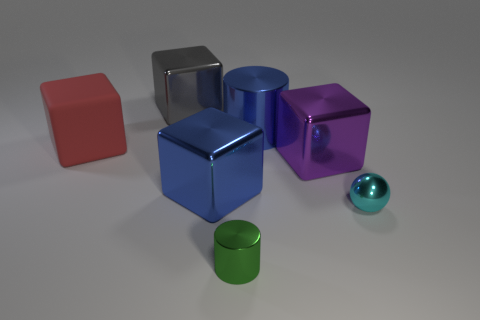Is there any other thing that has the same material as the red object?
Provide a short and direct response. No. What number of big gray things are on the right side of the blue shiny thing behind the big thing that is to the left of the gray block?
Keep it short and to the point. 0. How many green objects are either metal objects or metallic blocks?
Offer a very short reply. 1. What shape is the blue thing in front of the purple metal block?
Offer a very short reply. Cube. What is the color of the rubber block that is the same size as the purple thing?
Provide a succinct answer. Red. There is a large red rubber object; does it have the same shape as the tiny object to the left of the purple object?
Keep it short and to the point. No. What material is the big block that is on the left side of the large cube that is behind the cylinder that is right of the green cylinder?
Provide a short and direct response. Rubber. How many big things are cyan metallic things or red balls?
Make the answer very short. 0. What number of other things are the same size as the ball?
Make the answer very short. 1. There is a large metal object that is to the left of the large blue metal cube; does it have the same shape as the green object?
Offer a terse response. No. 